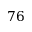<formula> <loc_0><loc_0><loc_500><loc_500>7 6</formula> 